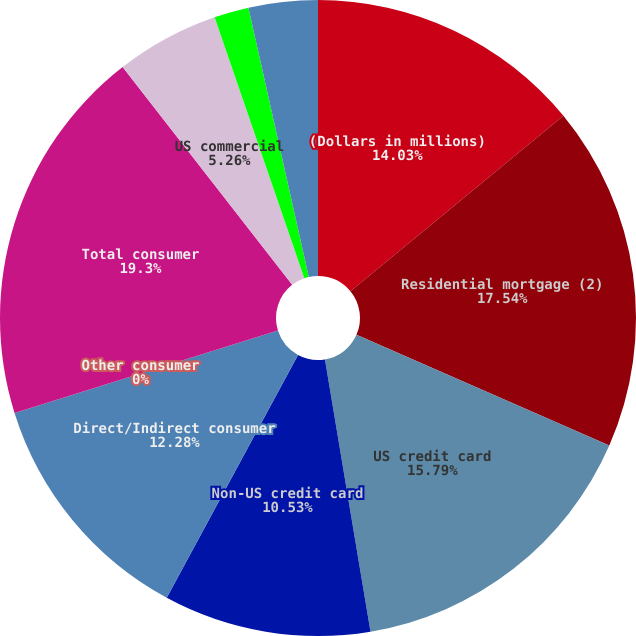<chart> <loc_0><loc_0><loc_500><loc_500><pie_chart><fcel>(Dollars in millions)<fcel>Residential mortgage (2)<fcel>US credit card<fcel>Non-US credit card<fcel>Direct/Indirect consumer<fcel>Other consumer<fcel>Total consumer<fcel>US commercial<fcel>Commercial real estate<fcel>Commercial lease financing<nl><fcel>14.03%<fcel>17.54%<fcel>15.79%<fcel>10.53%<fcel>12.28%<fcel>0.0%<fcel>19.3%<fcel>5.26%<fcel>1.76%<fcel>3.51%<nl></chart> 